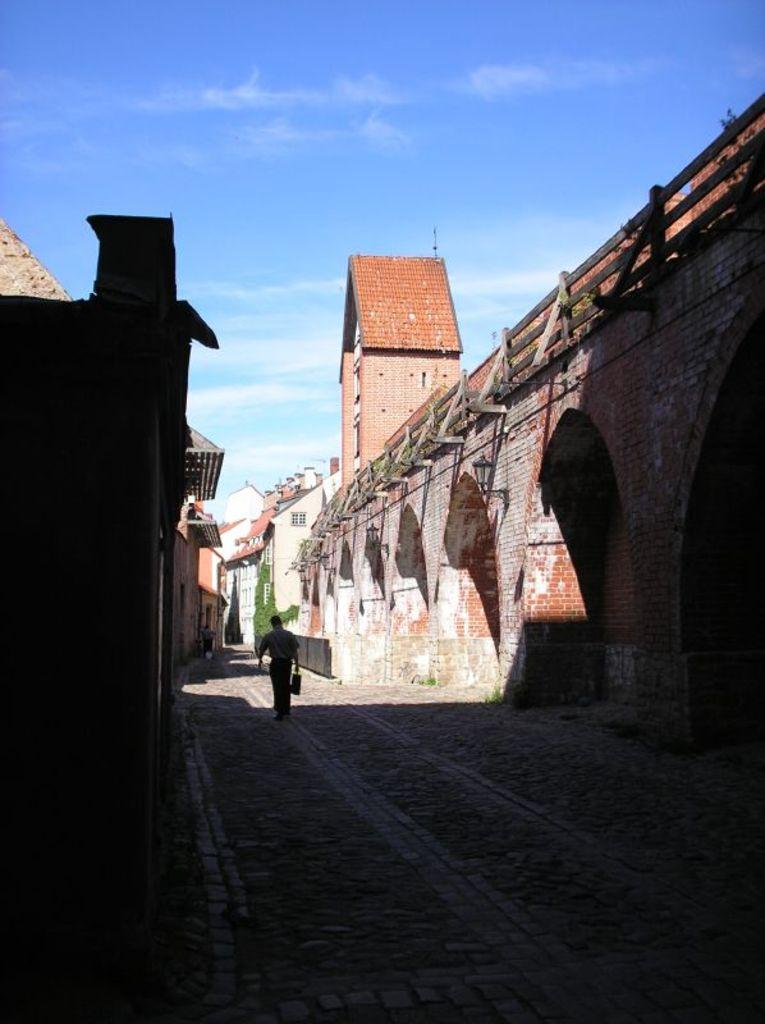What is the main subject of the image? There is a person walking in the middle of the image. What can be seen on either side of the person? There are buildings on either side of the image. What is visible at the top of the image? The sky is visible at the top of the image. What type of vegetation is in the background of the image? There are plants in the background of the image. What religious text is the person reading in the image? There is no indication in the image that the person is reading any religious text. 